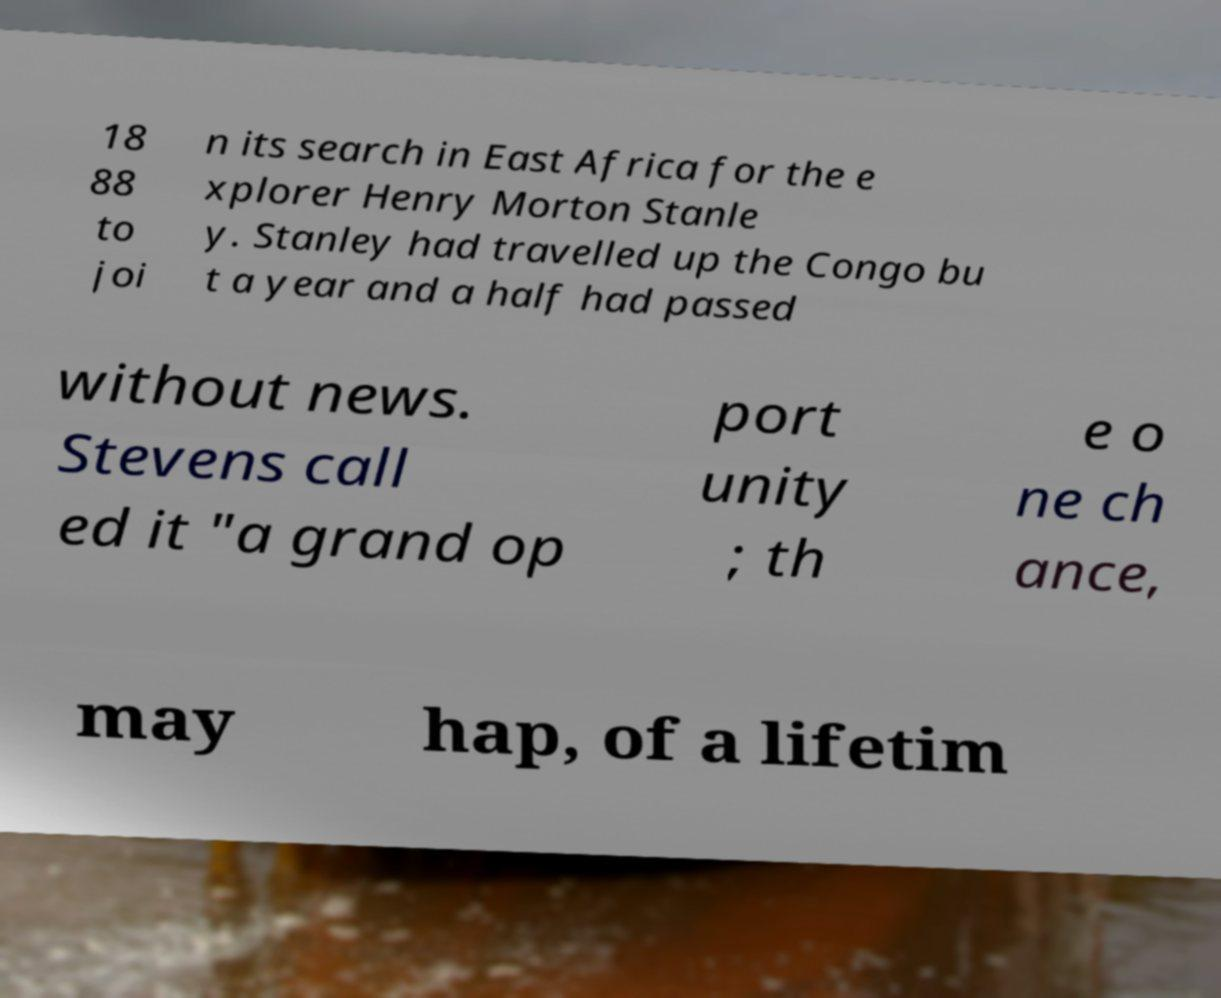For documentation purposes, I need the text within this image transcribed. Could you provide that? 18 88 to joi n its search in East Africa for the e xplorer Henry Morton Stanle y. Stanley had travelled up the Congo bu t a year and a half had passed without news. Stevens call ed it "a grand op port unity ; th e o ne ch ance, may hap, of a lifetim 